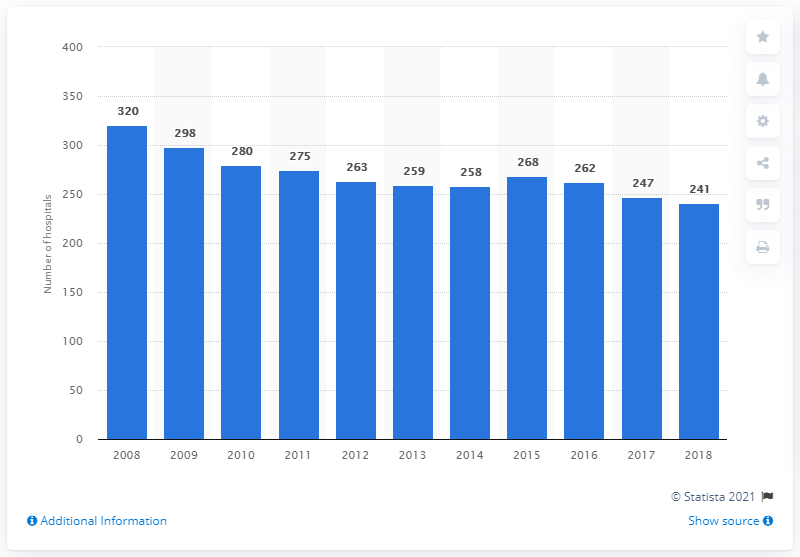Indicate a few pertinent items in this graphic. As of 2018, there were 241 hospitals in Finland. In 2008, there were 320 hospitals in Finland. 